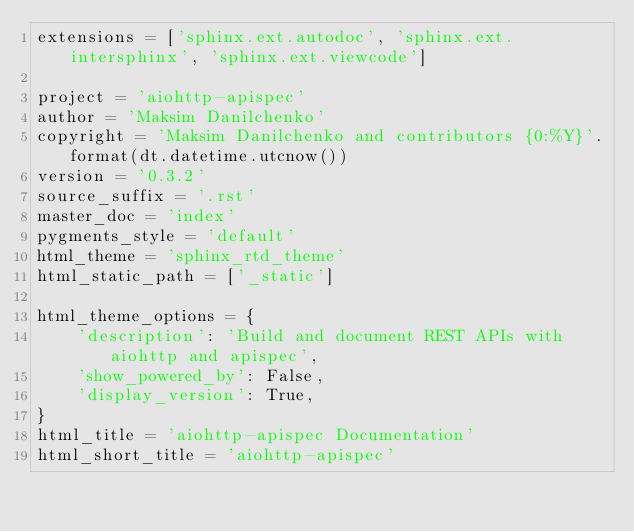<code> <loc_0><loc_0><loc_500><loc_500><_Python_>extensions = ['sphinx.ext.autodoc', 'sphinx.ext.intersphinx', 'sphinx.ext.viewcode']

project = 'aiohttp-apispec'
author = 'Maksim Danilchenko'
copyright = 'Maksim Danilchenko and contributors {0:%Y}'.format(dt.datetime.utcnow())
version = '0.3.2'
source_suffix = '.rst'
master_doc = 'index'
pygments_style = 'default'
html_theme = 'sphinx_rtd_theme'
html_static_path = ['_static']

html_theme_options = {
    'description': 'Build and document REST APIs with aiohttp and apispec',
    'show_powered_by': False,
    'display_version': True,
}
html_title = 'aiohttp-apispec Documentation'
html_short_title = 'aiohttp-apispec'
</code> 